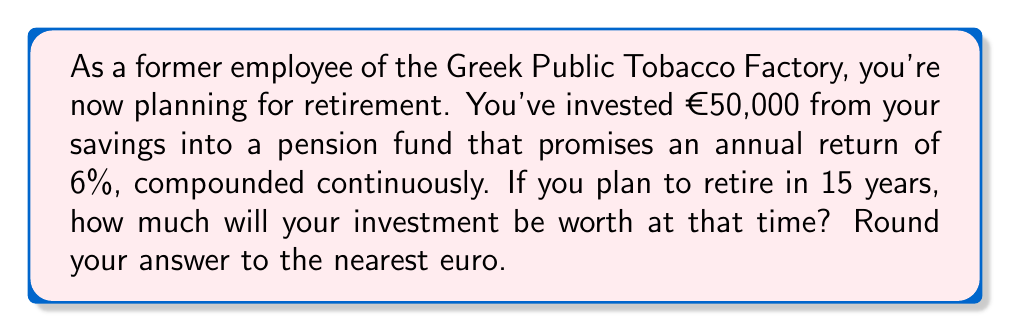Give your solution to this math problem. To solve this problem, we'll use the continuous compound interest formula:

$$A = P \cdot e^{rt}$$

Where:
$A$ = Final amount
$P$ = Principal (initial investment)
$r$ = Annual interest rate (as a decimal)
$t$ = Time in years
$e$ = Euler's number (approximately 2.71828)

Given:
$P = €50,000$
$r = 0.06$ (6% expressed as a decimal)
$t = 15$ years

Let's substitute these values into the formula:

$$A = 50000 \cdot e^{0.06 \cdot 15}$$

Now we can calculate:

$$A = 50000 \cdot e^{0.9}$$
$$A = 50000 \cdot 2.4596$$
$$A = 122980$$

Rounding to the nearest euro, we get €122,980.
Answer: €122,980 